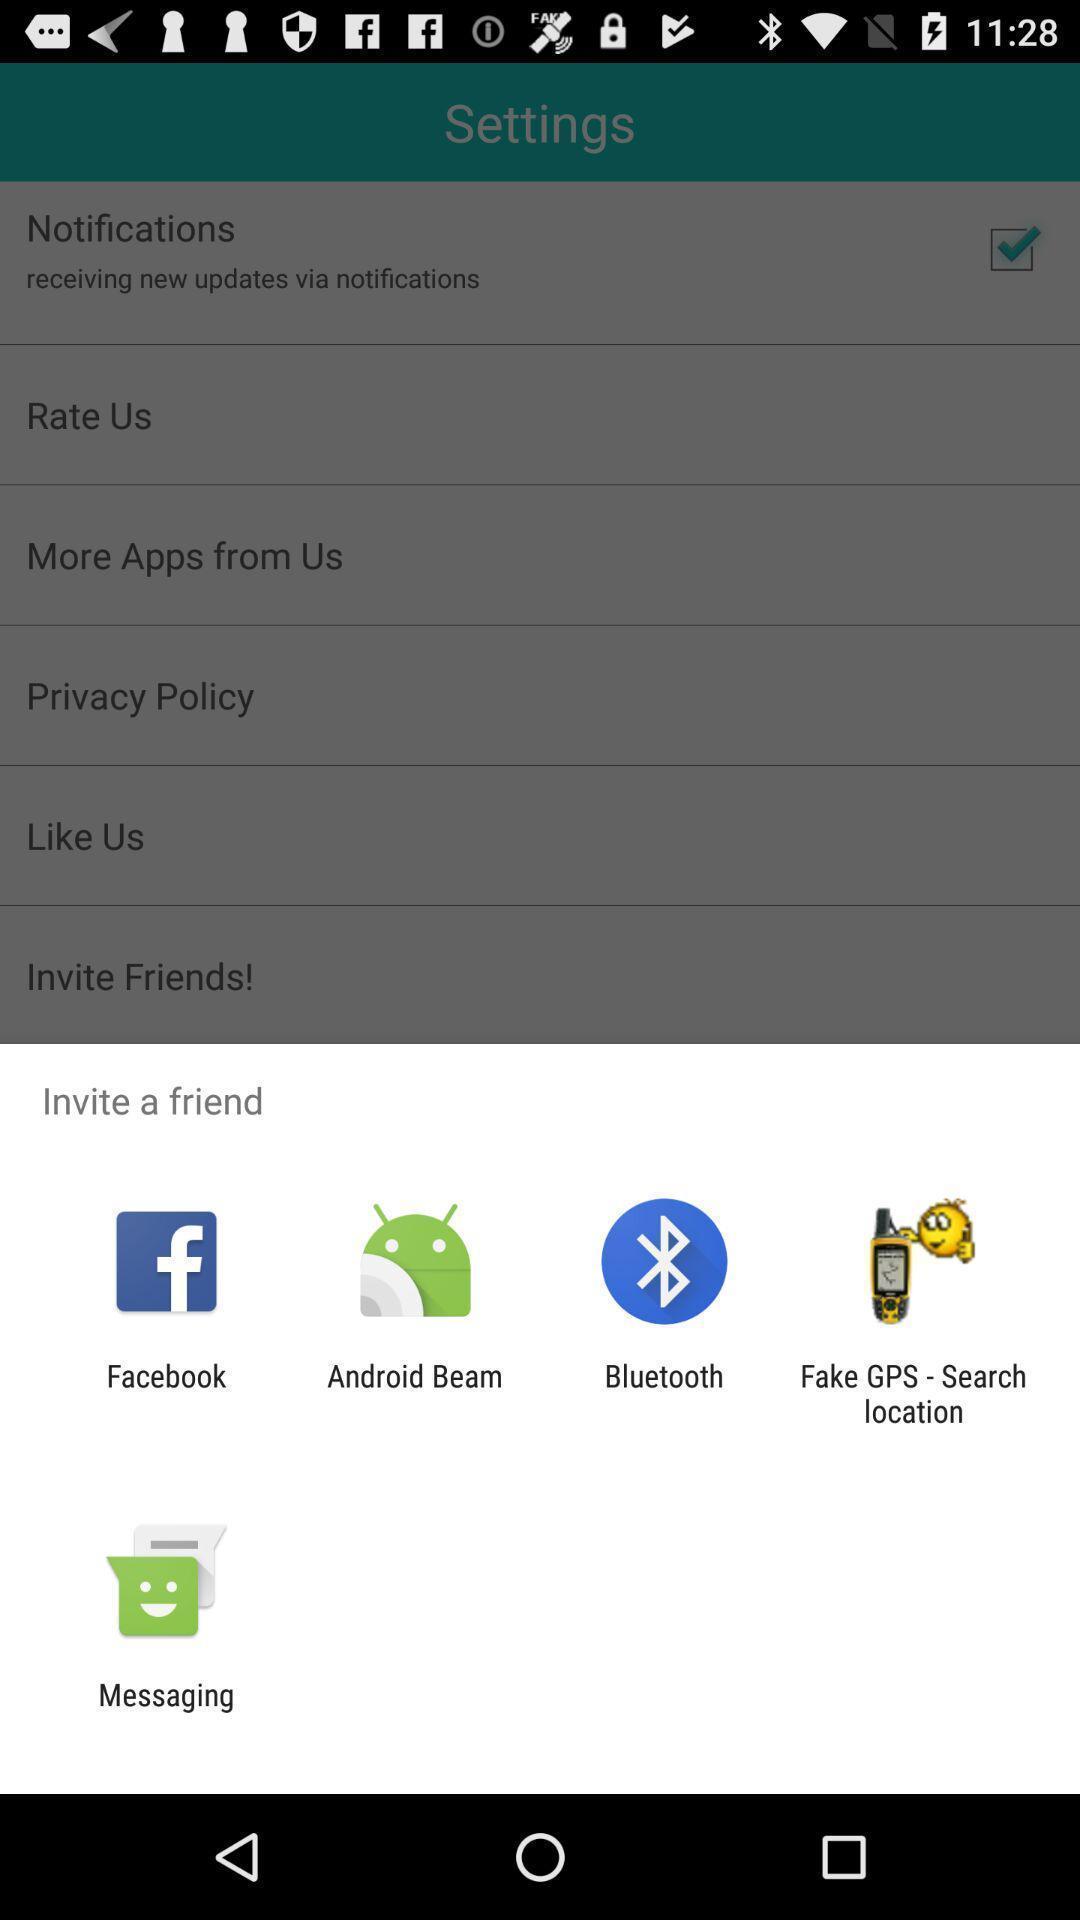What is the overall content of this screenshot? Widget displaying different sharing apps. 